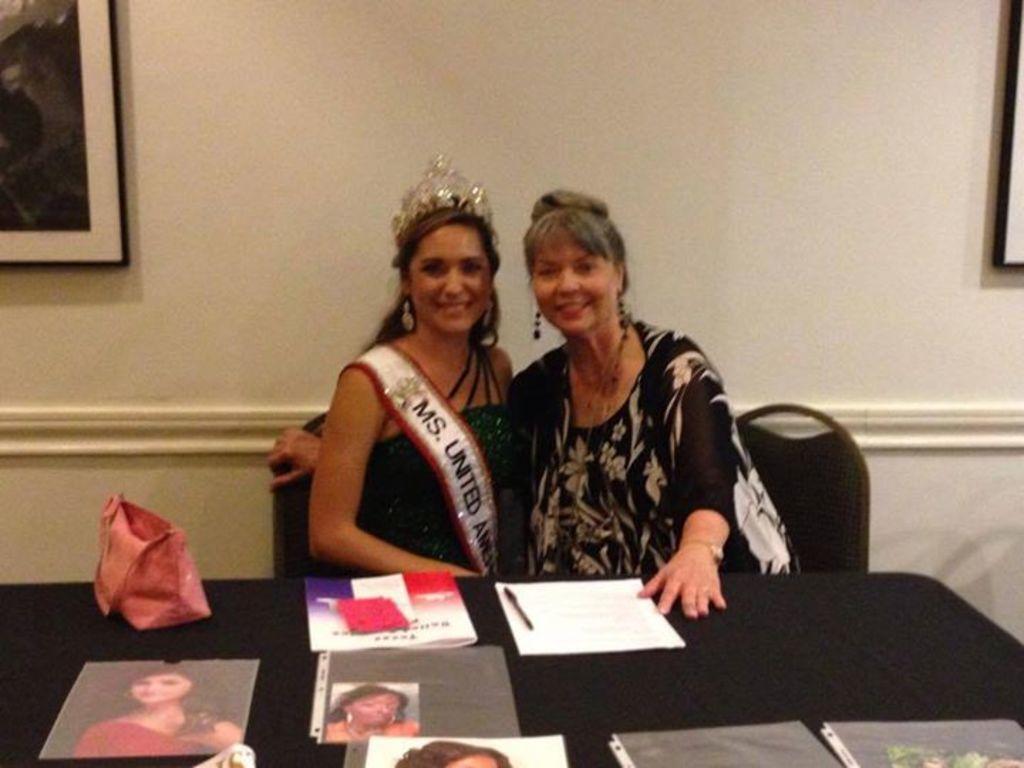In one or two sentences, can you explain what this image depicts? Here we can see two people are sitting on the chair and smiling, and in front here is the table and papers and some objects on it, and at back here is the wall and photo frame on it. 